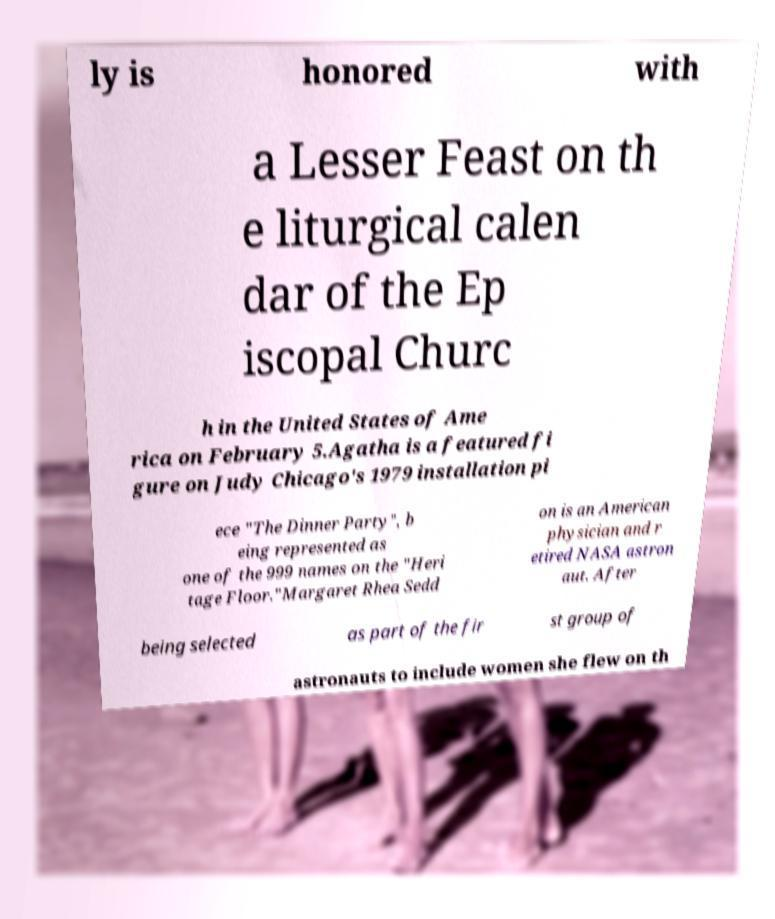Please identify and transcribe the text found in this image. ly is honored with a Lesser Feast on th e liturgical calen dar of the Ep iscopal Churc h in the United States of Ame rica on February 5.Agatha is a featured fi gure on Judy Chicago's 1979 installation pi ece "The Dinner Party", b eing represented as one of the 999 names on the "Heri tage Floor."Margaret Rhea Sedd on is an American physician and r etired NASA astron aut. After being selected as part of the fir st group of astronauts to include women she flew on th 